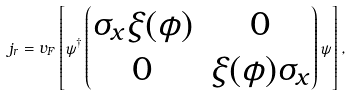<formula> <loc_0><loc_0><loc_500><loc_500>j _ { r } = v _ { F } \left [ \psi ^ { \dag } \begin{pmatrix} \sigma _ { x } \xi ( \phi ) & 0 \\ 0 & \xi ( \phi ) \sigma _ { x } \end{pmatrix} \psi \right ] ,</formula> 